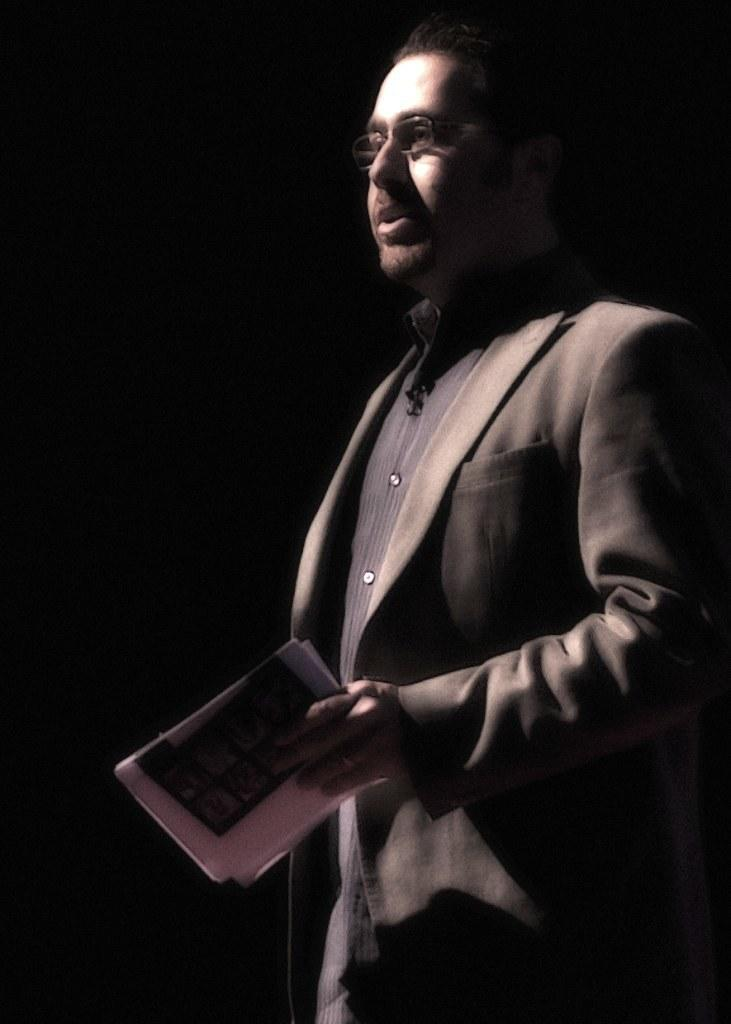Who is present in the image? There is a man in the image. What is the man wearing? The man is wearing a suit. What is the man holding in his hand? The man is holding papers in his hand. What color is the background of the image? The background of the image is black. Can you see a locket around the man's neck in the image? There is no locket visible around the man's neck in the image. Is the man playing any musical instruments in the image? There is no indication that the man is playing any musical instruments in the image. 